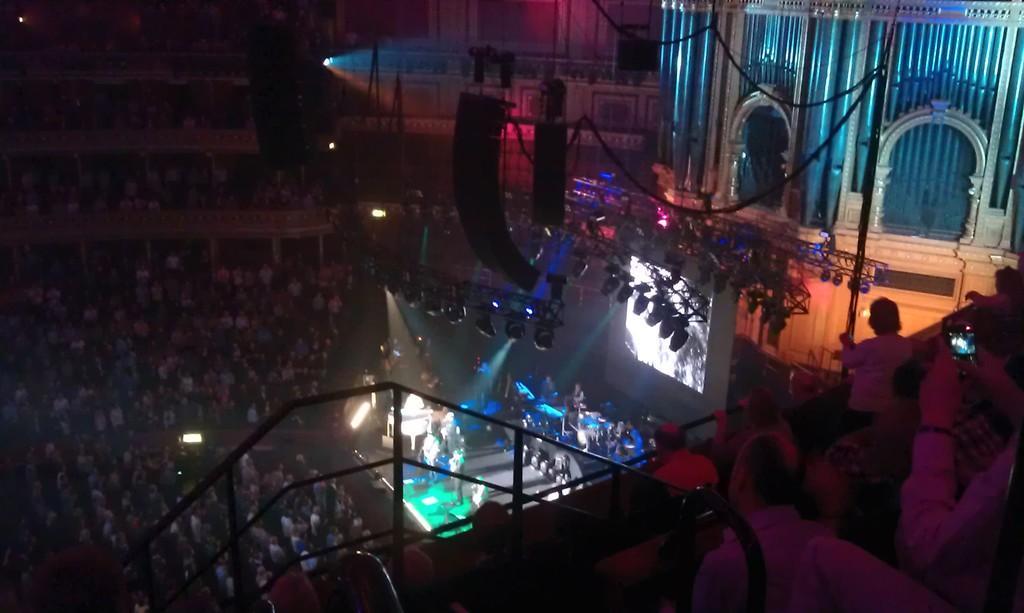Describe this image in one or two sentences. In this image I can see a group of people and few people are on the stage. I can see lights,buildings and few people are holding mobiles. The image is dark. 